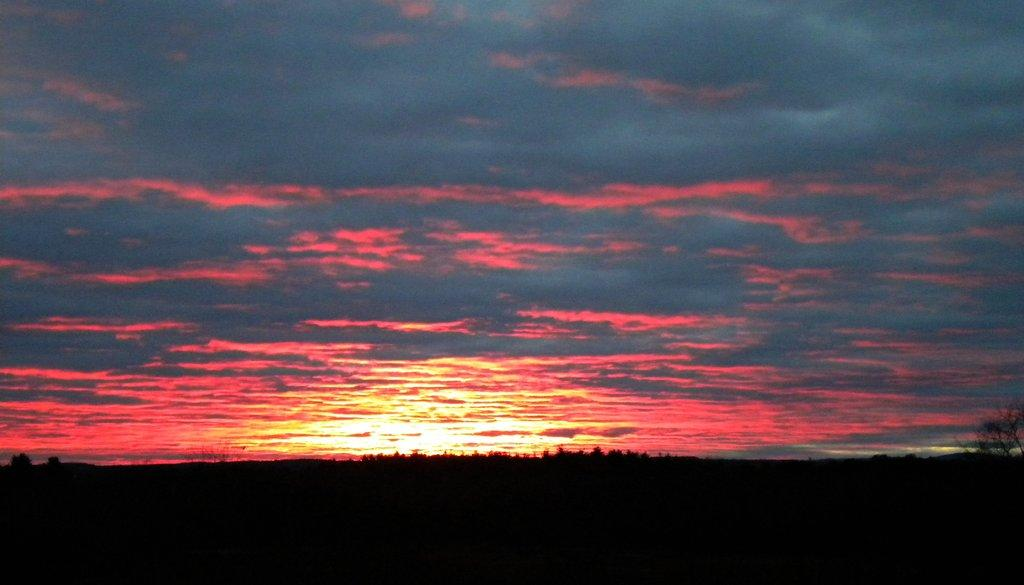What can be seen at the top of the image? The sky is visible in the image. What is the condition of the sky in the image? The sky has an orange color. What type of natural elements can be seen in the background of the image? There are many trees in the background of the image. Are there any clouds visible in the sky? Yes, clouds are present in the sky. How many cherries are hanging from the net in the image? There are no cherries or nets present in the image. 